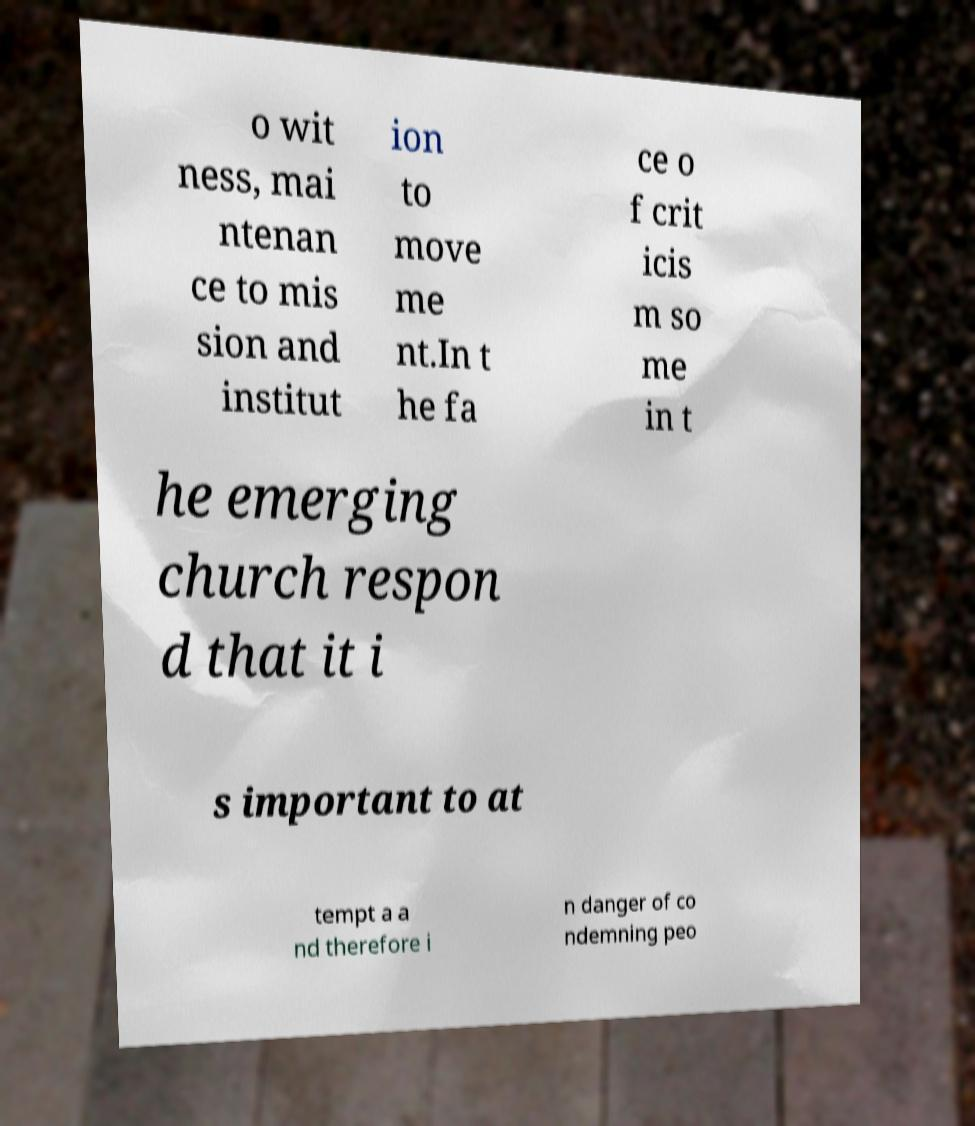Could you assist in decoding the text presented in this image and type it out clearly? o wit ness, mai ntenan ce to mis sion and institut ion to move me nt.In t he fa ce o f crit icis m so me in t he emerging church respon d that it i s important to at tempt a a nd therefore i n danger of co ndemning peo 